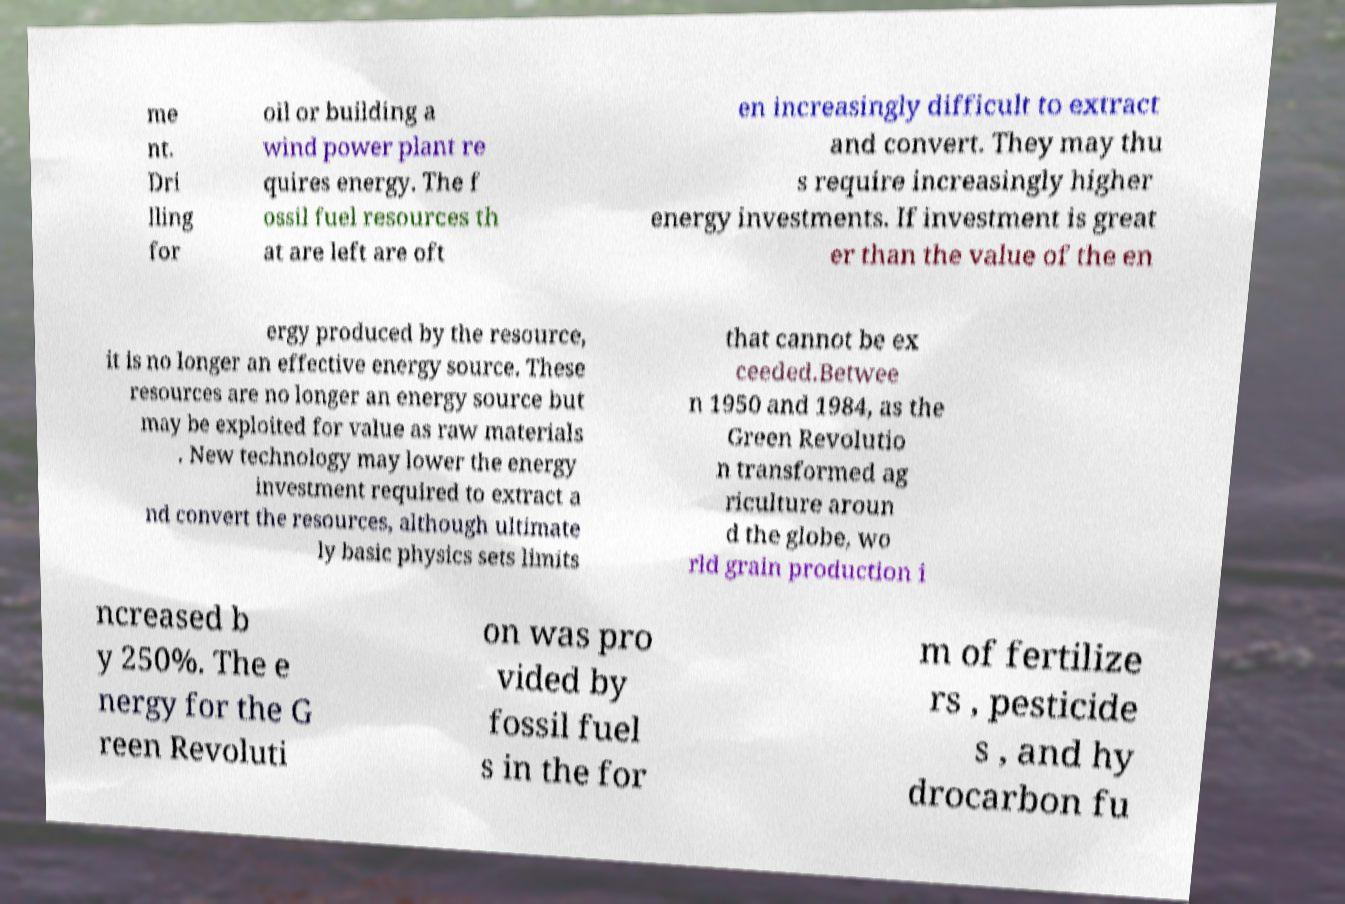What messages or text are displayed in this image? I need them in a readable, typed format. me nt. Dri lling for oil or building a wind power plant re quires energy. The f ossil fuel resources th at are left are oft en increasingly difficult to extract and convert. They may thu s require increasingly higher energy investments. If investment is great er than the value of the en ergy produced by the resource, it is no longer an effective energy source. These resources are no longer an energy source but may be exploited for value as raw materials . New technology may lower the energy investment required to extract a nd convert the resources, although ultimate ly basic physics sets limits that cannot be ex ceeded.Betwee n 1950 and 1984, as the Green Revolutio n transformed ag riculture aroun d the globe, wo rld grain production i ncreased b y 250%. The e nergy for the G reen Revoluti on was pro vided by fossil fuel s in the for m of fertilize rs , pesticide s , and hy drocarbon fu 